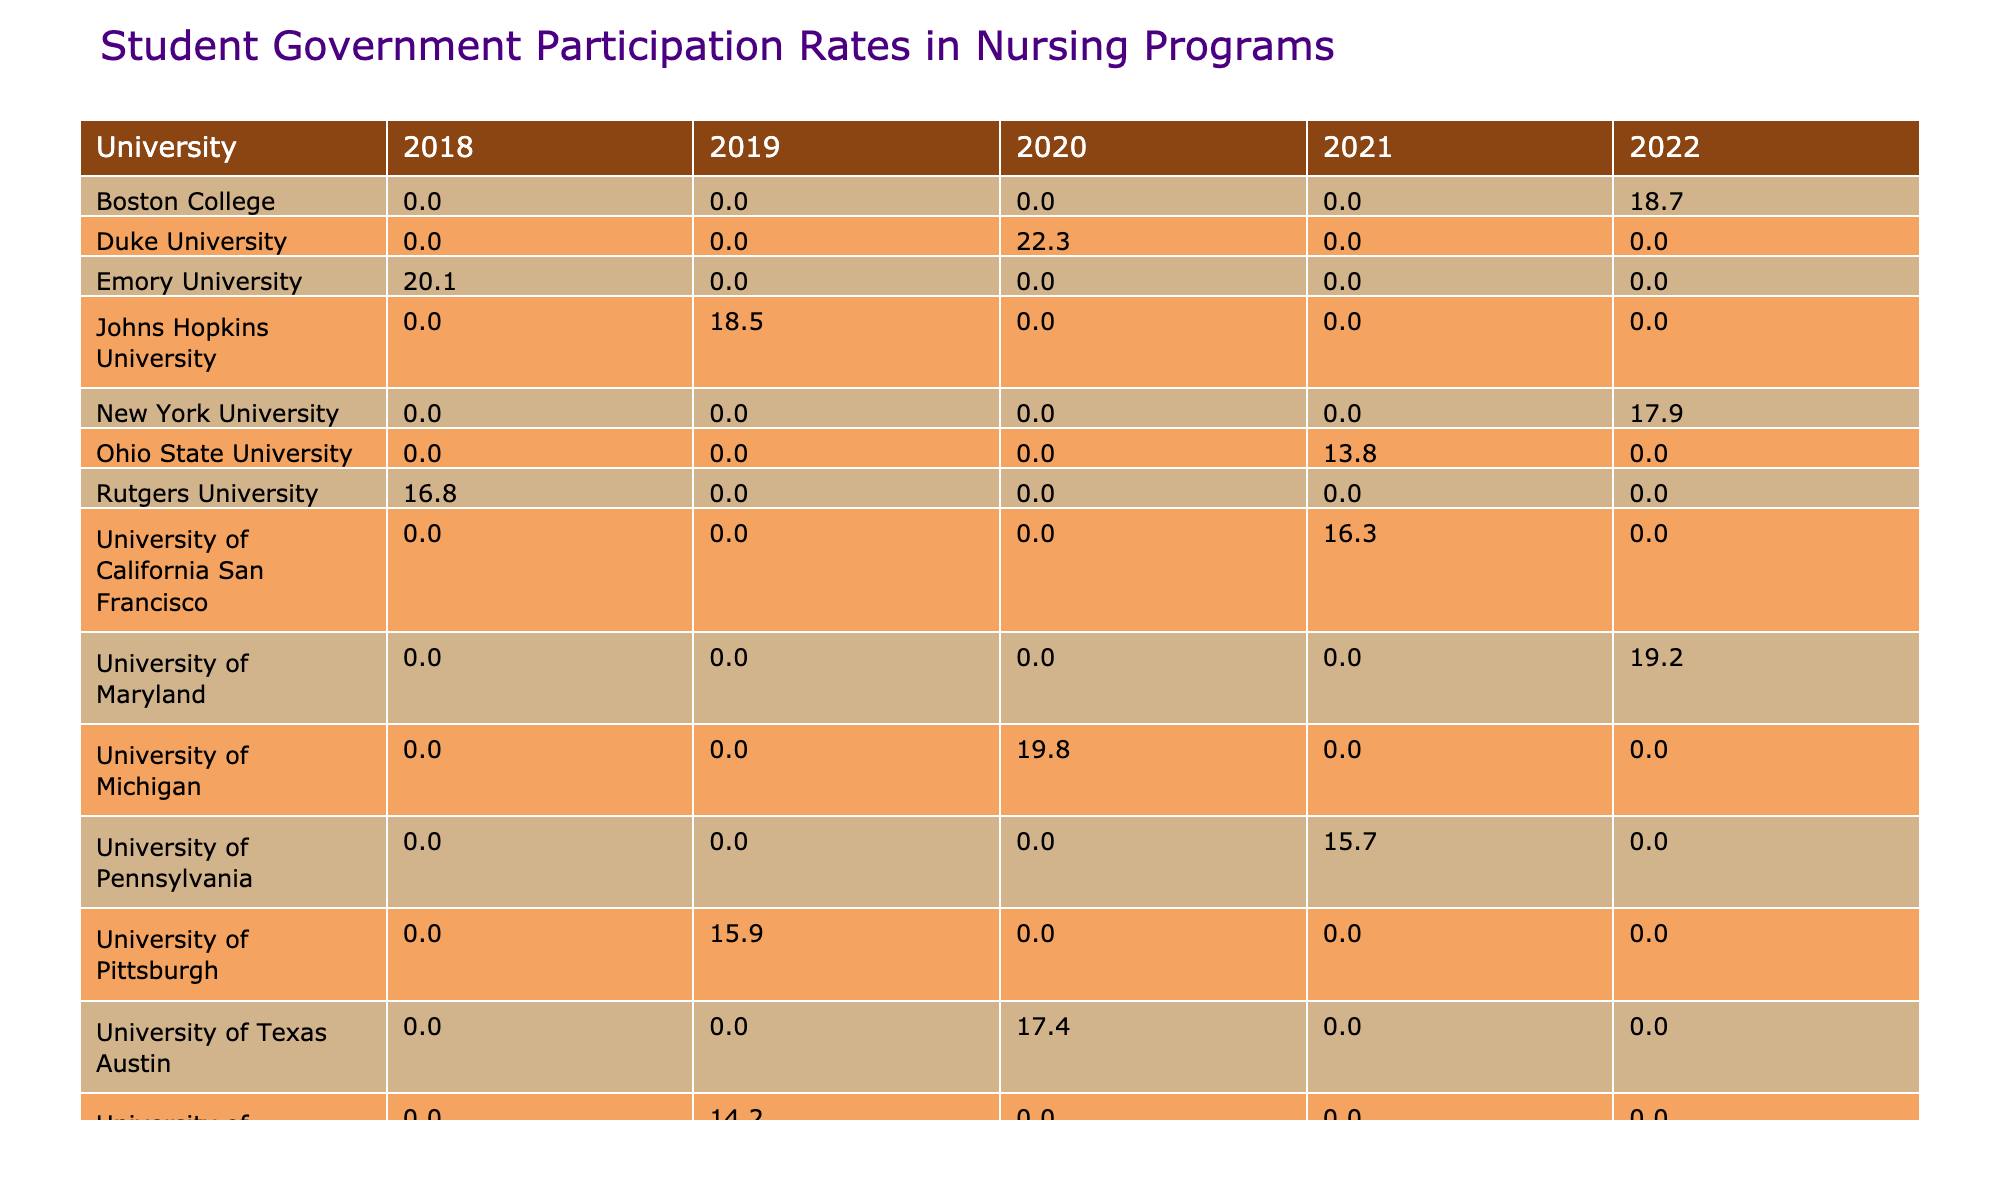What was the participation rate for Duke University in 2020? The table lists the participation rates by university and year. For Duke University in 2020, the participation rate is directly provided in the table.
Answer: 22.3 Which university had the highest participation rate in the year 2018? By inspecting the 2018 column of the table, the participation rates can be compared. Vanderbilt University has the highest participation rate in 2018 at 21.5.
Answer: Vanderbilt University Calculate the average participation rate for the years 2019 and 2020. For 2019 the participation rates are: 18.5 (Johns Hopkins), 14.2 (University of Washington), 15.9 (University of Pittsburgh), which sum up to 48.6. For 2020, rates are: 22.3 (Duke), 19.8 (University of Michigan), and 17.4 (University of Texas Austin), leading to a sum of 59.5. The average is (48.6 + 59.5) / 6 = 17.68.
Answer: 17.68 Is it true that the University of Maryland had a participation rate higher than 20% in 2022? In the 2022 data column, the University of Maryland's participation rate of 19.2 is compared to 20. There are no entries above 20 for that year. Thus, the statement is false.
Answer: No What is the difference between the highest and lowest participation rates in 2021? In 2021, the highest participation rate belongs to the University of Pennsylvania with 15.7, while the lowest is Ohio State University with 13.8. The difference is 15.7 - 13.8 = 1.9.
Answer: 1.9 Which university had a participation rate of 16.8 in 2018? By searching the 2018 column in the table, we find that Rutgers University has a participation rate of 16.8.
Answer: Rutgers University Determine the total participation rate for all universities in 2020. The participation rates for 2020 are summed as follows: 22.3 (Duke) + 19.8 (University of Michigan) + 17.4 (University of Texas Austin) = 59.5. Therefore, the total is 59.5.
Answer: 59.5 What percentage of the universities listed had a participation rate below 16% in 2019? Analyzing the 2019 column, the participation rates below 16% belong to University of Washington (14.2) and University of Pittsburgh (15.9). There are 2 such universities out of 8 total, making the percentage 2/8 = 25%.
Answer: 25% Which years had participation rates below 18% for the University of Pittsburgh? The University of Pittsburgh had a rate of 15.9 in 2019 and there are no entries for other years. Therefore, 2019 is the only year listed with a rate below 18%.
Answer: 2019 Identify the university with the lowest participation rate in the 2022 category. In the 2022 column, participation rates show New York University with a rate of 17.9 and Boston College with 18.7. Thus, New York University has the lowest participation rate in 2022.
Answer: New York University 